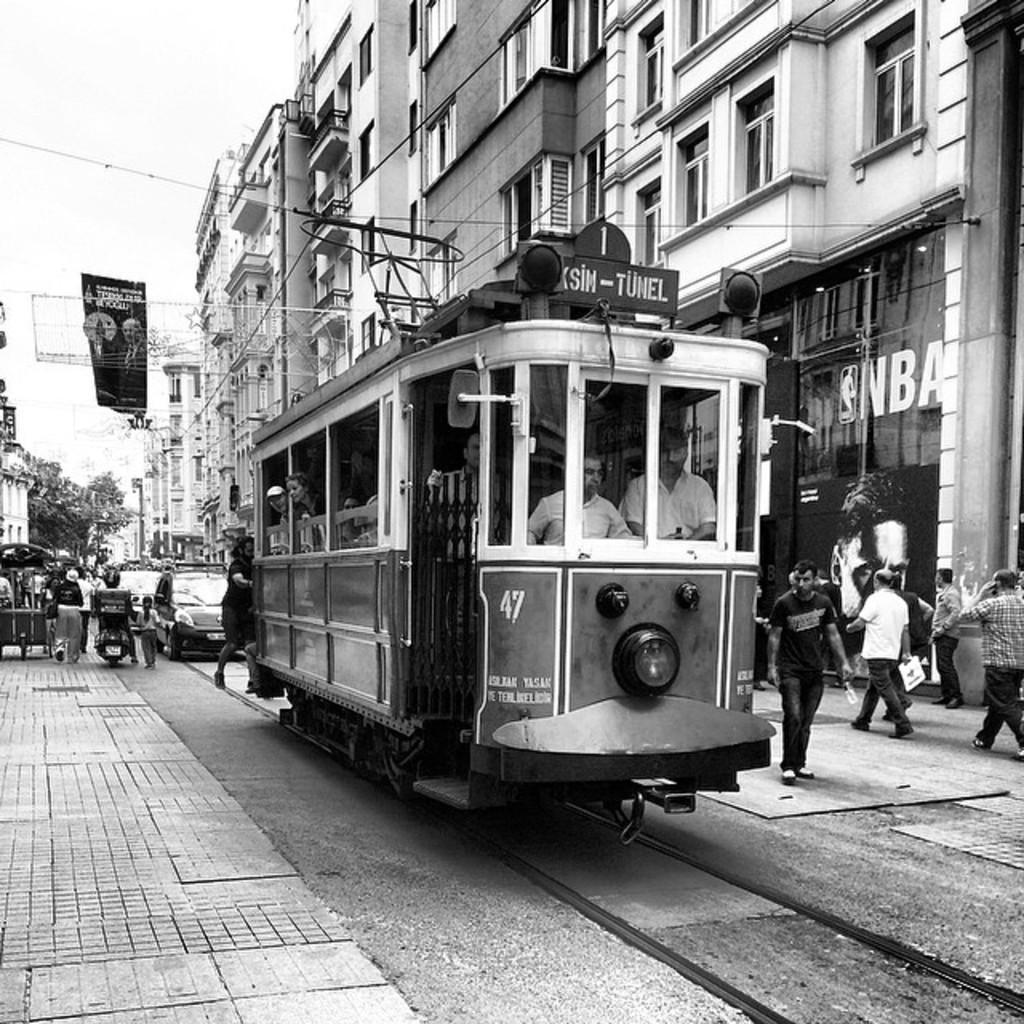What is the color scheme of the image? The image is black and white. What can be seen on the road in the image? There are vehicles and people on the road. What is visible in the background of the image? There are buildings, boards, trees, and the sky visible in the background. What type of seed can be seen growing on the side of the road in the image? There is no seed visible in the image; the image is black and white, and the focus is on vehicles, people, and background elements. 